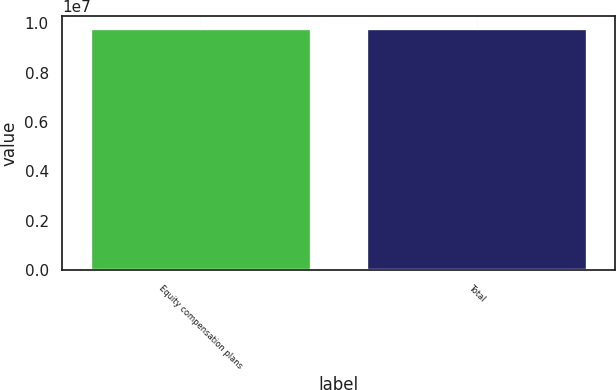Convert chart to OTSL. <chart><loc_0><loc_0><loc_500><loc_500><bar_chart><fcel>Equity compensation plans<fcel>Total<nl><fcel>9.821e+06<fcel>9.821e+06<nl></chart> 